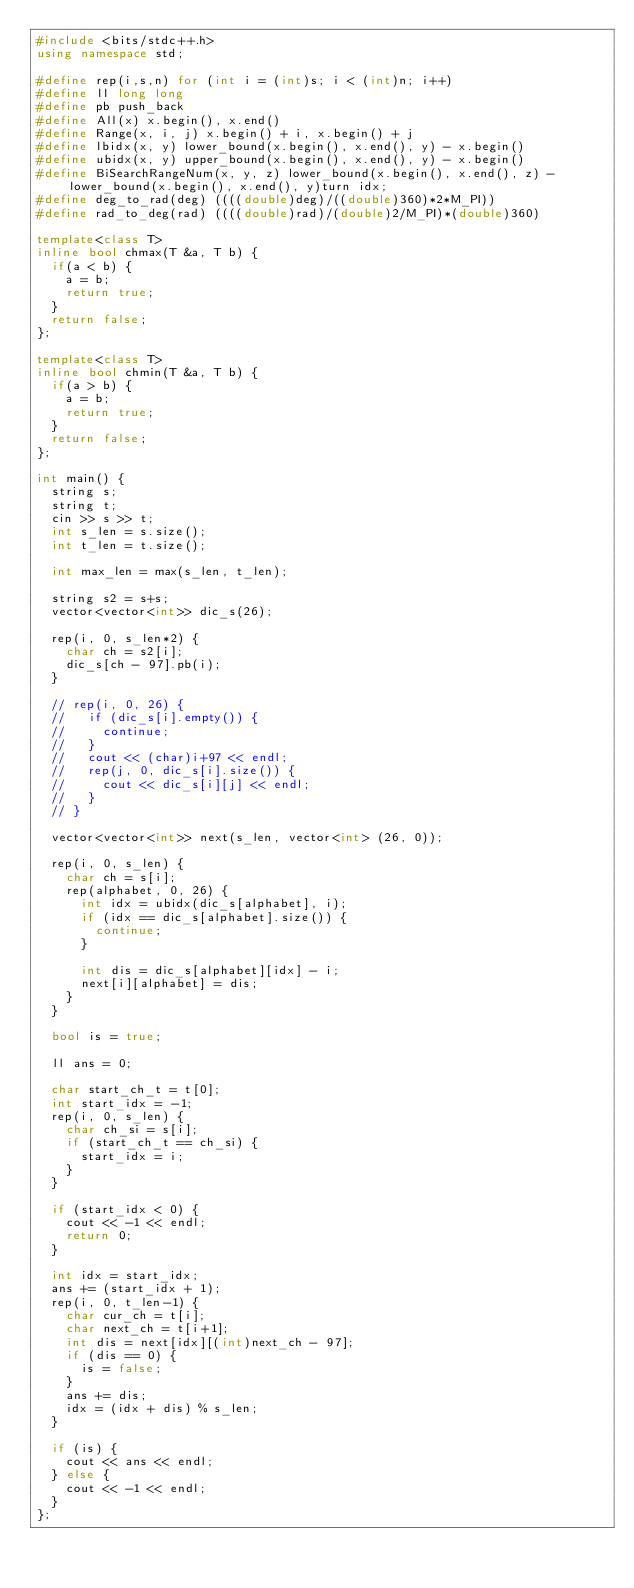Convert code to text. <code><loc_0><loc_0><loc_500><loc_500><_C++_>#include <bits/stdc++.h>
using namespace std;

#define rep(i,s,n) for (int i = (int)s; i < (int)n; i++)
#define ll long long
#define pb push_back
#define All(x) x.begin(), x.end()
#define Range(x, i, j) x.begin() + i, x.begin() + j
#define lbidx(x, y) lower_bound(x.begin(), x.end(), y) - x.begin()
#define ubidx(x, y) upper_bound(x.begin(), x.end(), y) - x.begin()
#define BiSearchRangeNum(x, y, z) lower_bound(x.begin(), x.end(), z) - lower_bound(x.begin(), x.end(), y)turn idx;
#define deg_to_rad(deg) ((((double)deg)/((double)360)*2*M_PI))
#define rad_to_deg(rad) ((((double)rad)/(double)2/M_PI)*(double)360)

template<class T>
inline bool chmax(T &a, T b) {
  if(a < b) {
    a = b;
    return true;
  }
  return false;
};

template<class T>
inline bool chmin(T &a, T b) {
  if(a > b) {
    a = b;
    return true;
  }
  return false;
};

int main() {
  string s;
  string t;
  cin >> s >> t;
  int s_len = s.size();
  int t_len = t.size();

  int max_len = max(s_len, t_len);

  string s2 = s+s;
  vector<vector<int>> dic_s(26);

  rep(i, 0, s_len*2) {
    char ch = s2[i];
    dic_s[ch - 97].pb(i);
  }

  // rep(i, 0, 26) {
  //   if (dic_s[i].empty()) {
  //     continue;
  //   }
  //   cout << (char)i+97 << endl;
  //   rep(j, 0, dic_s[i].size()) {
  //     cout << dic_s[i][j] << endl;
  //   }
  // }

  vector<vector<int>> next(s_len, vector<int> (26, 0));

  rep(i, 0, s_len) {
    char ch = s[i];
    rep(alphabet, 0, 26) {
      int idx = ubidx(dic_s[alphabet], i);
      if (idx == dic_s[alphabet].size()) {
        continue;
      }

      int dis = dic_s[alphabet][idx] - i;
      next[i][alphabet] = dis;
    }
  }

  bool is = true;

  ll ans = 0;

  char start_ch_t = t[0];
  int start_idx = -1;
  rep(i, 0, s_len) {
    char ch_si = s[i];
    if (start_ch_t == ch_si) {
      start_idx = i;
    }
  }

  if (start_idx < 0) {
    cout << -1 << endl;
    return 0;
  }

  int idx = start_idx;
  ans += (start_idx + 1);
  rep(i, 0, t_len-1) {
    char cur_ch = t[i];
    char next_ch = t[i+1];
    int dis = next[idx][(int)next_ch - 97];
    if (dis == 0) {
      is = false;
    }
    ans += dis;
    idx = (idx + dis) % s_len;
  }

  if (is) {
    cout << ans << endl;
  } else {
    cout << -1 << endl;
  }
};
</code> 